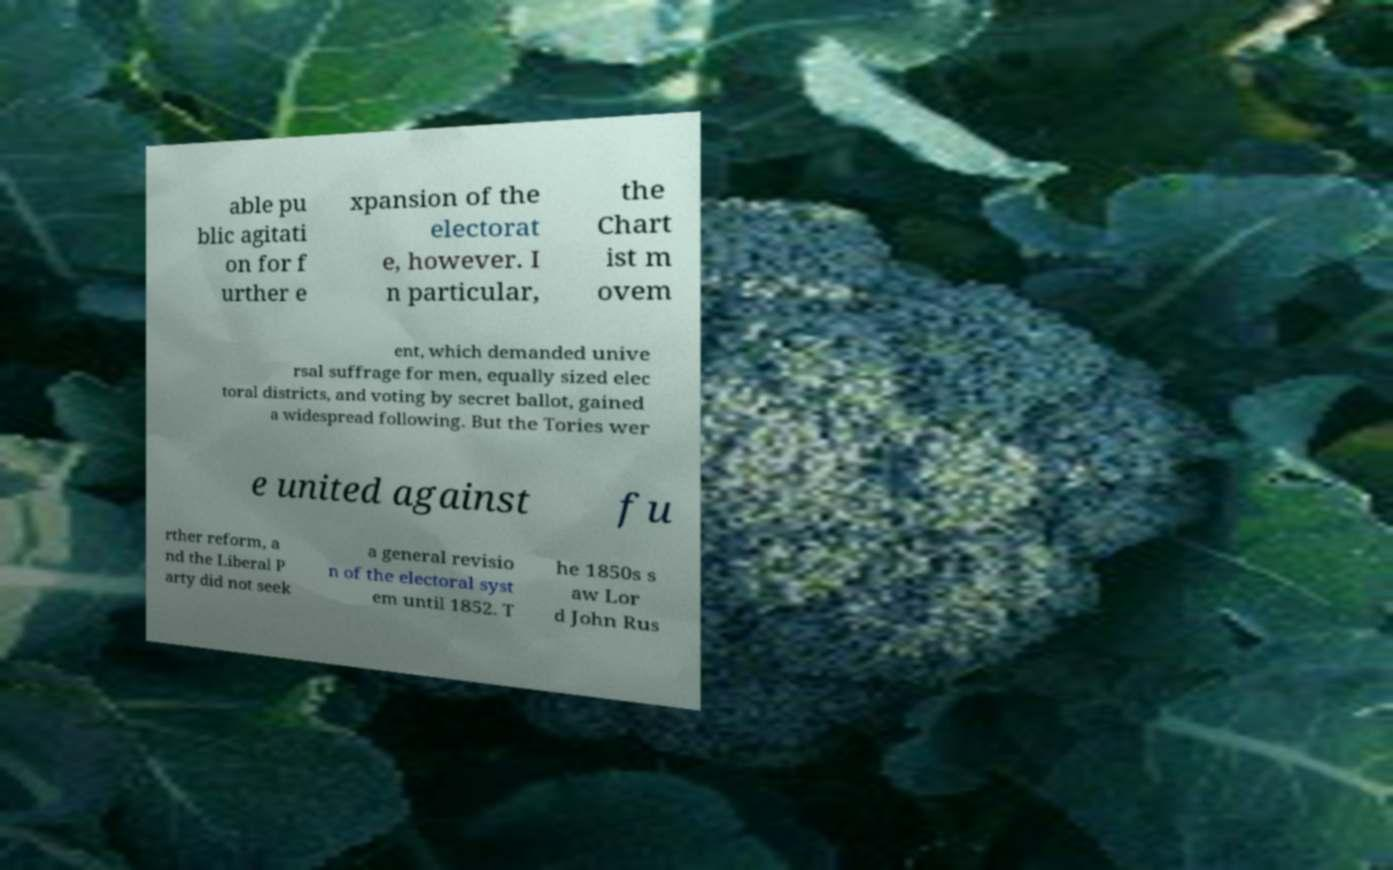Could you extract and type out the text from this image? able pu blic agitati on for f urther e xpansion of the electorat e, however. I n particular, the Chart ist m ovem ent, which demanded unive rsal suffrage for men, equally sized elec toral districts, and voting by secret ballot, gained a widespread following. But the Tories wer e united against fu rther reform, a nd the Liberal P arty did not seek a general revisio n of the electoral syst em until 1852. T he 1850s s aw Lor d John Rus 